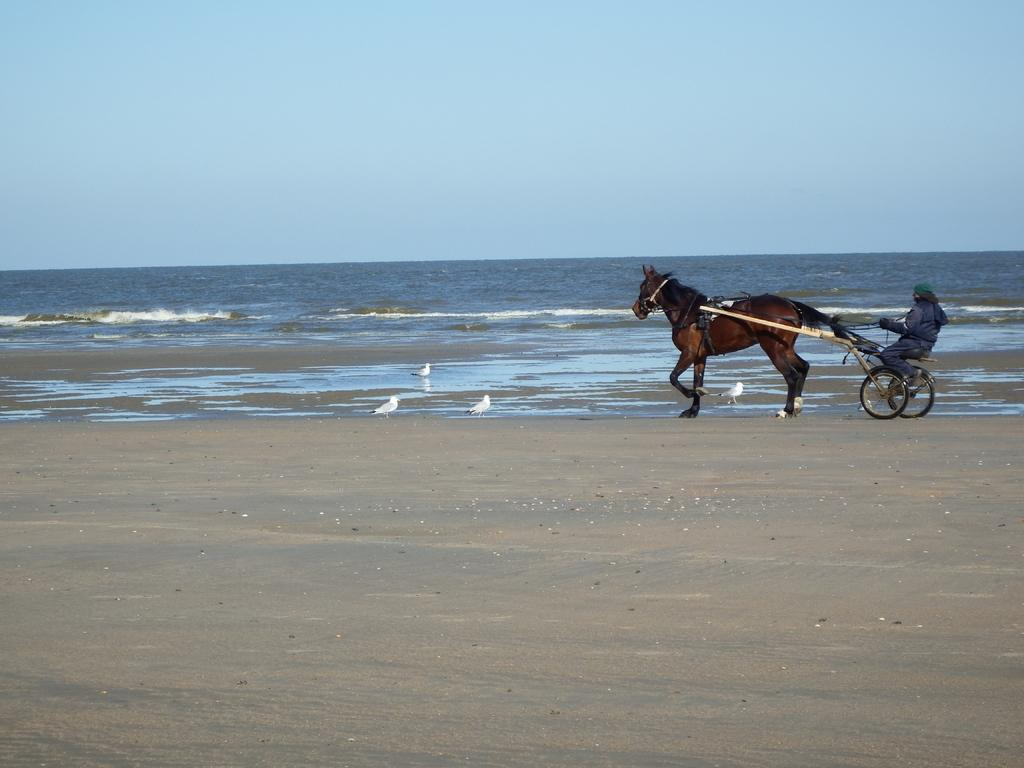What animal is present in the image? There is a horse in the image. What other living creatures can be seen on the ground? There are birds on the ground in the image. Who is riding the horse? There is a person sitting at the back of the horse. What can be seen in the distance in the image? There is water and sky visible in the background of the image. What type of plant is being used as a kissing booth in the image? There is no plant or kissing booth present in the image. 